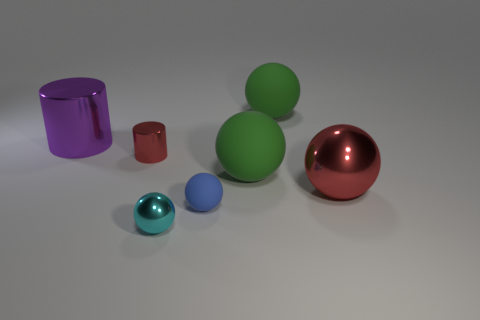Can you describe the shapes and colors present in this image? Certainly! The image displays a collection of geometric shapes with a sleek finish. There's a large green sphere, a reflective red sphere, and a smaller blue sphere. We also see a tall purple cylinder and a smaller red cube. All the objects have a metallic luster and are placed against a neutral gray background. 